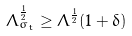Convert formula to latex. <formula><loc_0><loc_0><loc_500><loc_500>\Lambda _ { \sigma _ { t } } ^ { \frac { 1 } { 2 } } \geq \Lambda ^ { \frac { 1 } { 2 } } ( 1 + \delta )</formula> 